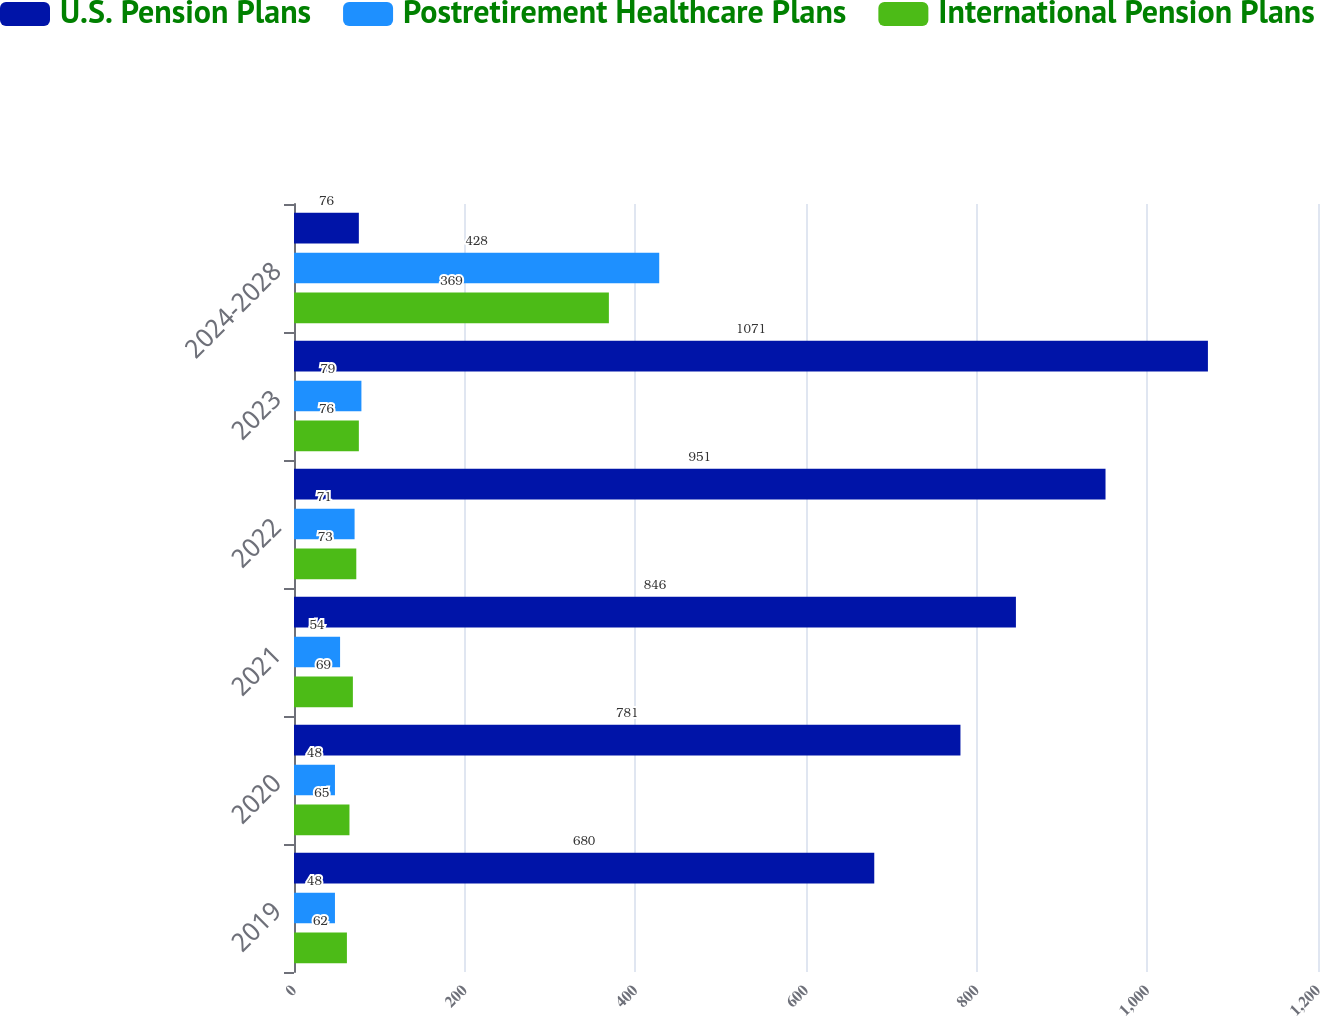<chart> <loc_0><loc_0><loc_500><loc_500><stacked_bar_chart><ecel><fcel>2019<fcel>2020<fcel>2021<fcel>2022<fcel>2023<fcel>2024-2028<nl><fcel>U.S. Pension Plans<fcel>680<fcel>781<fcel>846<fcel>951<fcel>1071<fcel>76<nl><fcel>Postretirement Healthcare Plans<fcel>48<fcel>48<fcel>54<fcel>71<fcel>79<fcel>428<nl><fcel>International Pension Plans<fcel>62<fcel>65<fcel>69<fcel>73<fcel>76<fcel>369<nl></chart> 